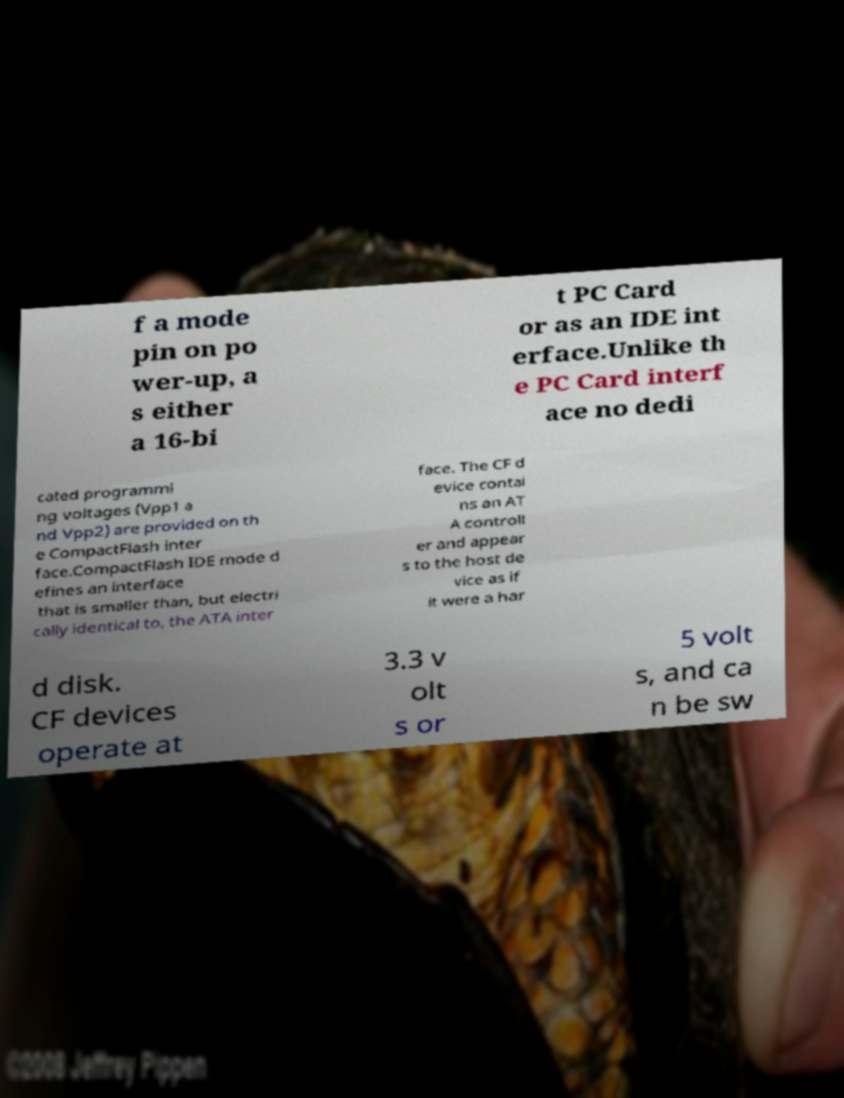Please read and relay the text visible in this image. What does it say? f a mode pin on po wer-up, a s either a 16-bi t PC Card or as an IDE int erface.Unlike th e PC Card interf ace no dedi cated programmi ng voltages (Vpp1 a nd Vpp2) are provided on th e CompactFlash inter face.CompactFlash IDE mode d efines an interface that is smaller than, but electri cally identical to, the ATA inter face. The CF d evice contai ns an AT A controll er and appear s to the host de vice as if it were a har d disk. CF devices operate at 3.3 v olt s or 5 volt s, and ca n be sw 